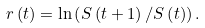Convert formula to latex. <formula><loc_0><loc_0><loc_500><loc_500>r \left ( t \right ) = \ln \left ( S \left ( t + 1 \right ) / S \left ( t \right ) \right ) .</formula> 